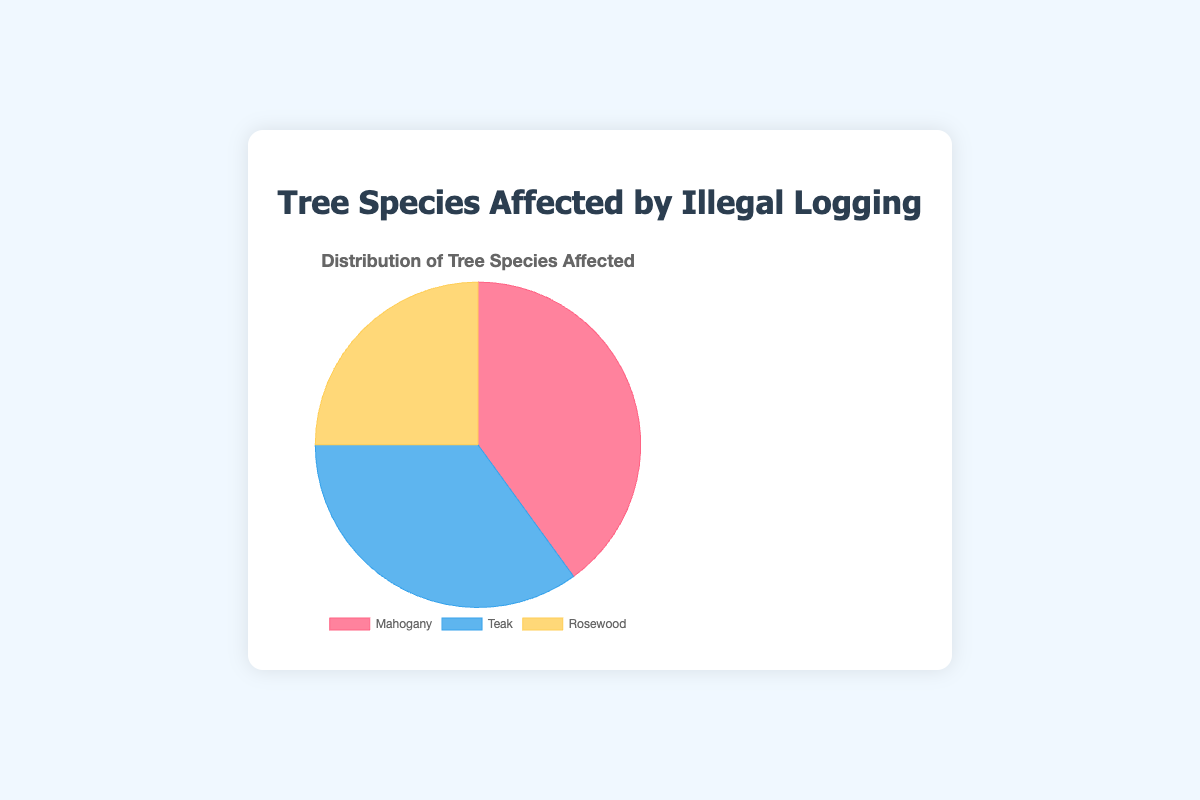What percentage of the affected tree species is Mahogany? Mahogany accounts for 40% of the slices shown in the pie chart.
Answer: 40% Which tree species is least affected by illegal logging? By looking at the chart, Rosewood has the smallest slice which represents 25%.
Answer: Rosewood How much more percentage of Teak is affected compared to Rosewood? Teak is at 35%, and Rosewood is at 25%. The difference is 35% - 25% = 10%.
Answer: 10% What is the ratio of Mahogany to Teak in terms of percentage affected? Mahogany is at 40% and Teak is at 35%. The ratio of Mahogany to Teak is 40:35. Simplifying this, it becomes 8:7.
Answer: 8:7 What is the total percentage of Teak and Rosewood combined? Teak is at 35% and Rosewood is at 25%. Adding them together, we get 35% + 25% = 60%.
Answer: 60% If the total affected area is 100 hectares, how many hectares do Mahogany trees account for? Mahogany represents 40%. 40% of 100 hectares is (40/100) * 100 = 40 hectares.
Answer: 40 hectares Which tree species represents the second largest portion in the pie chart? Teak, as it represents 35% which is the second largest portion after Mahogany.
Answer: Teak Combine the percentage of Mahogany and Rosewood and compare it to Teak. Is it greater or lesser? By how much? Mahogany is 40% and Rosewood is 25%, so together they are 65%. Teak is 35%. The combined percentage of Mahogany and Rosewood is greater by 65% - 35% = 30%.
Answer: Greater by 30% What percentage of the affected tree species is neither Mahogany nor Teak? Rosewood is the only species left when excluding Mahogany and Teak. Rosewood accounts for 25%.
Answer: 25% Is the percentage of Teak affected closer to Mahogany or Rosewood? Mahogany is at 40% and Rosewood is at 25%, with Teak at 35%. The difference between Teak and Mahogany is 40% - 35% = 5%, and the difference between Teak and Rosewood is 35% - 25% = 10%. Therefore, the percentage of Teak is closer to Mahogany.
Answer: Mahogany 